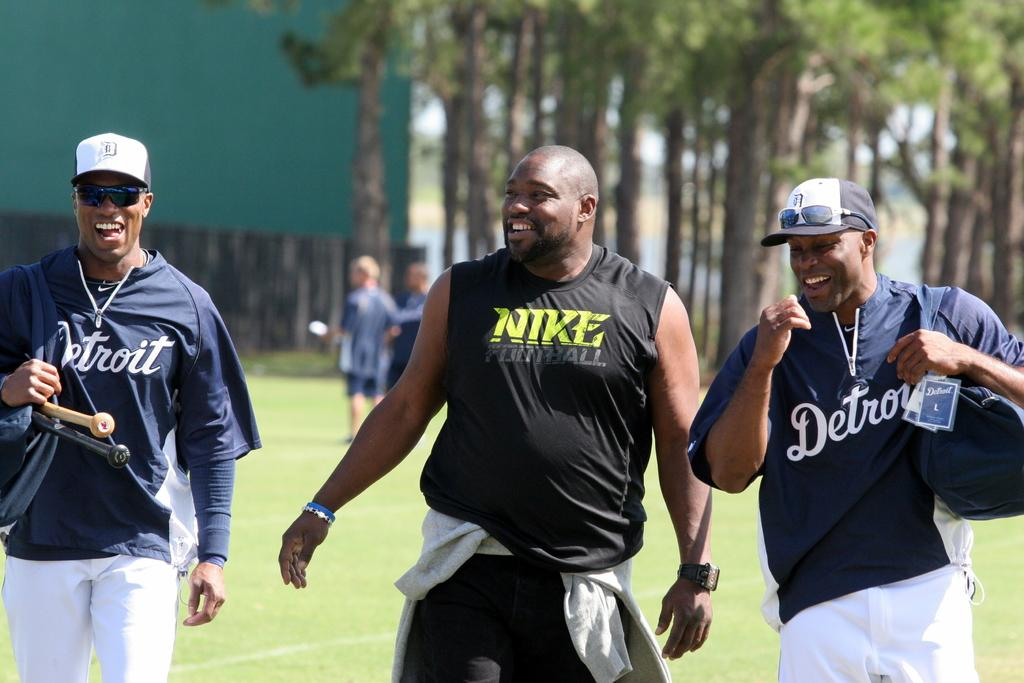<image>
Give a short and clear explanation of the subsequent image. Two men wearing shirts that say Detroit walk on either side of a man wearing a Nike Football shirt. 